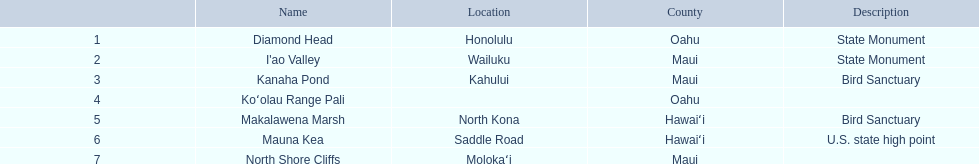What are all the landmark names? Diamond Head, I'ao Valley, Kanaha Pond, Koʻolau Range Pali, Makalawena Marsh, Mauna Kea, North Shore Cliffs. Which county is each landlord in? Oahu, Maui, Maui, Oahu, Hawaiʻi, Hawaiʻi, Maui. Along with mauna kea, which landmark is in hawai'i county? Makalawena Marsh. 